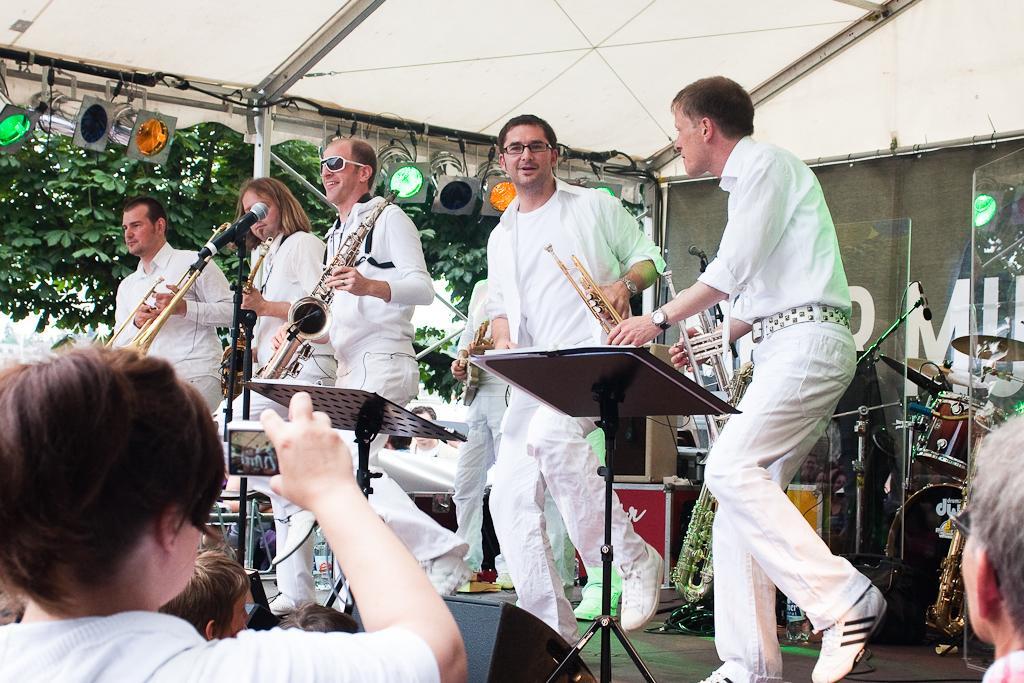How would you summarize this image in a sentence or two? In this image we can see a few people, among them some people are playing the musical instruments on the stage, behind them, we can see some other musical instruments on the stage, there are some stands, lights and trees. 